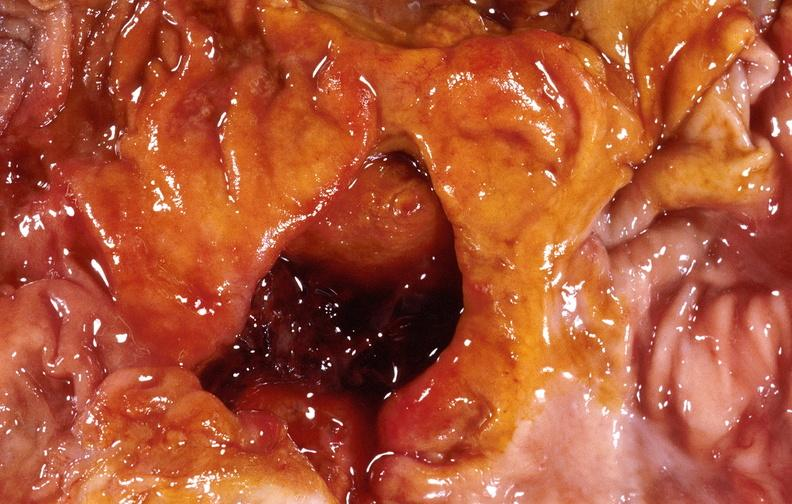where does this belong to?
Answer the question using a single word or phrase. Gastrointestinal system 